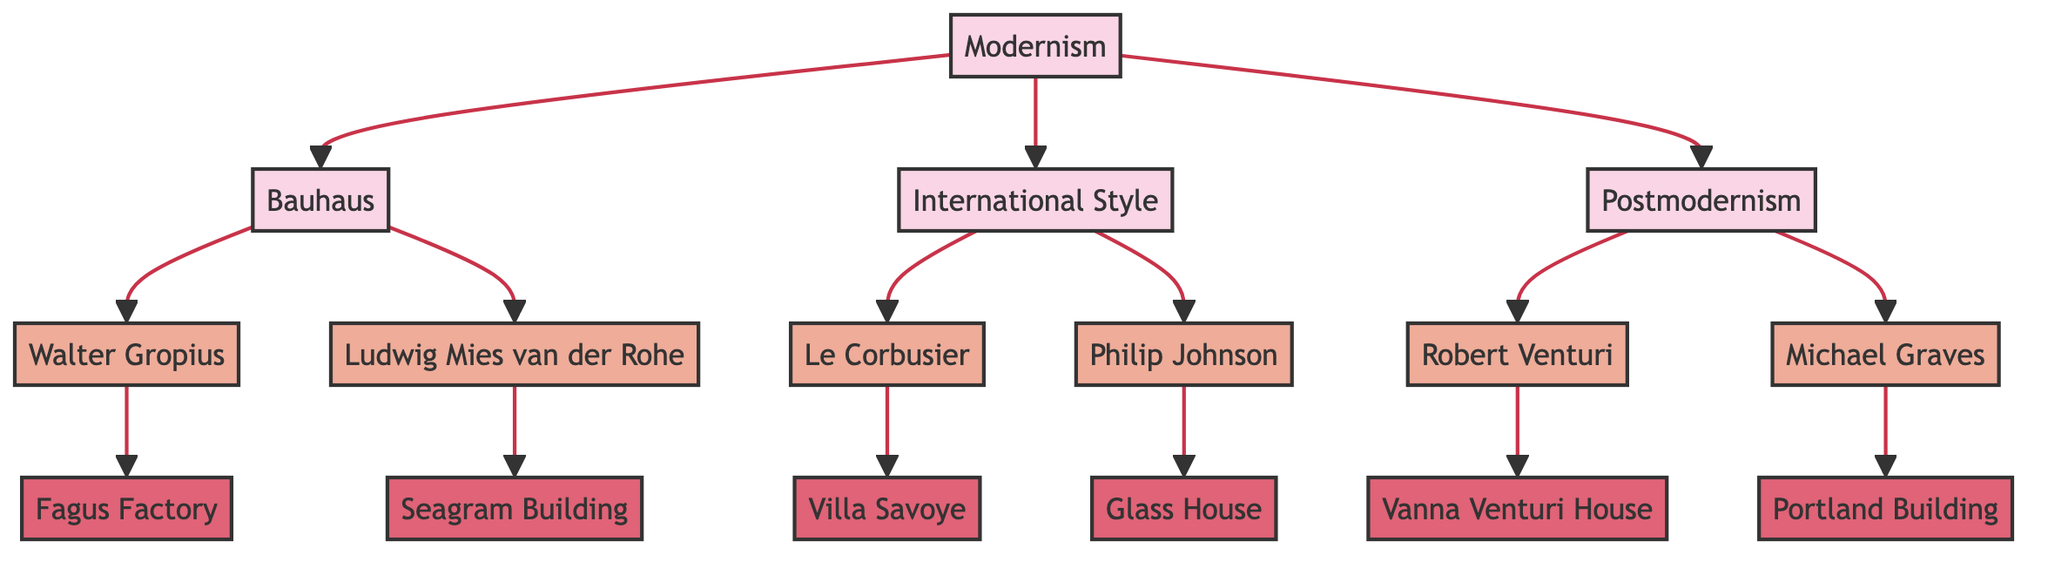What is the primary architectural movement depicted in the diagram? The title of the diagram states "Evolution of Modern Architecture Influences," indicating the focus on Modernism as the central movement.
Answer: Modernism How many architectural movements are represented in the diagram? By counting the nodes related to movements, we find four distinct movements: Modernism, Bauhaus, International Style, and Postmodernism.
Answer: 4 Which architect is connected to the Fagus Factory? The diagram shows that Walter Gropius is the architect linked directly to the Fagus Factory.
Answer: Walter Gropius What movement is Ludwig Mies van der Rohe associated with? Following the links in the diagram, Ludwig Mies van der Rohe is connected to the Bauhaus movement and, indirectly, to Modernism through his contributions.
Answer: Bauhaus Which building is associated with Robert Venturi? According to the diagram, Robert Venturi is connected to the Vanna Venturi House, which is specifically named as his design.
Answer: Vanna Venturi House Which two architects are associated with the International Style? The diagram shows that both Le Corbusier and Philip Johnson are directly linked to the International Style, as they are both connected to its node.
Answer: Le Corbusier and Philip Johnson Which architectural style emerged in the late 20th century? By examining the movement nodes, specifically Postmodernism, we see that it is characterized as a late 20th-century style.
Answer: Postmodernism What is the significance of the Glass House? The Glass House is highlighted as a residence designed by Philip Johnson that embodies the principles of the International Style, indicating its importance in this context.
Answer: Epitomizes International Style 